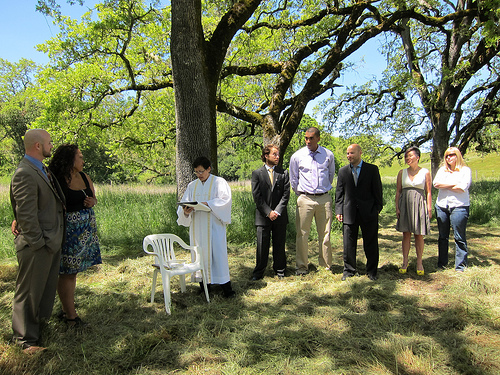<image>
Is there a woman to the left of the woman? Yes. From this viewpoint, the woman is positioned to the left side relative to the woman. 